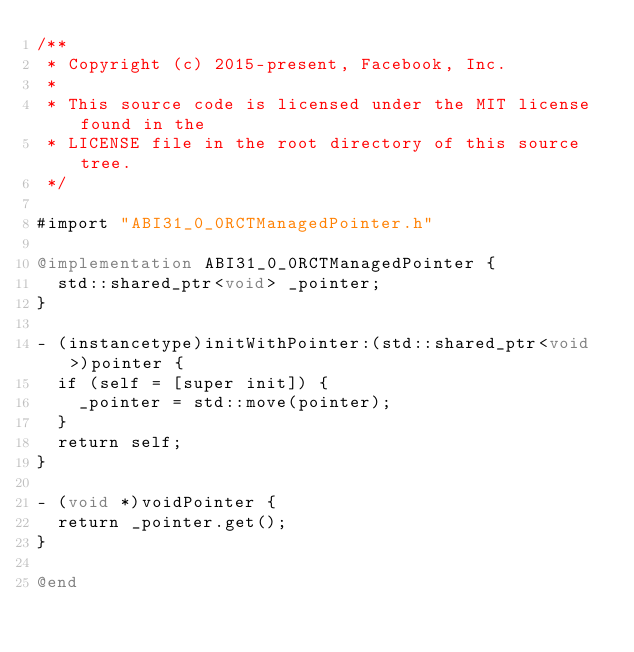<code> <loc_0><loc_0><loc_500><loc_500><_ObjectiveC_>/**
 * Copyright (c) 2015-present, Facebook, Inc.
 *
 * This source code is licensed under the MIT license found in the
 * LICENSE file in the root directory of this source tree.
 */

#import "ABI31_0_0RCTManagedPointer.h"

@implementation ABI31_0_0RCTManagedPointer {
  std::shared_ptr<void> _pointer;
}

- (instancetype)initWithPointer:(std::shared_ptr<void>)pointer {
  if (self = [super init]) {
    _pointer = std::move(pointer);
  }
  return self;
}

- (void *)voidPointer {
  return _pointer.get();
}

@end
</code> 